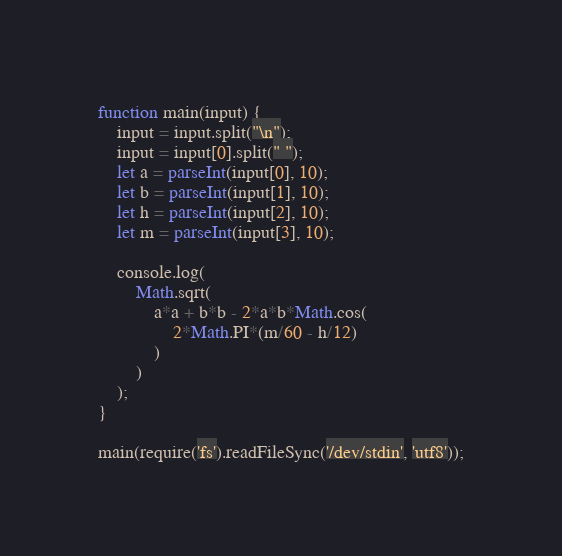<code> <loc_0><loc_0><loc_500><loc_500><_JavaScript_>function main(input) {
	input = input.split("\n");
  	input = input[0].split(" ");
  	let a = parseInt(input[0], 10);
  	let b = parseInt(input[1], 10);
  	let h = parseInt(input[2], 10);
  	let m = parseInt(input[3], 10);
  
  	console.log(
    	Math.sqrt(
        	a*a + b*b - 2*a*b*Math.cos(
            	2*Math.PI*(m/60 - h/12)
            )
        )
    );
}
 
main(require('fs').readFileSync('/dev/stdin', 'utf8'));
</code> 